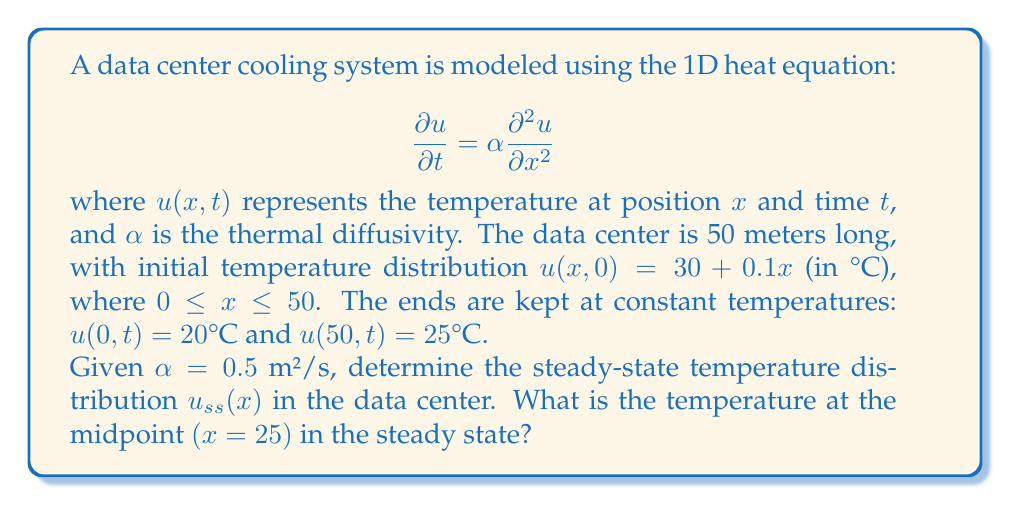Show me your answer to this math problem. To solve this problem, we'll follow these steps:

1) For the steady-state solution, the temperature doesn't change with time, so $\frac{\partial u}{\partial t} = 0$. The heat equation becomes:

   $$0 = \alpha \frac{d^2 u_{ss}}{dx^2}$$

2) Integrating twice:

   $$\frac{d u_{ss}}{dx} = C_1$$
   $$u_{ss}(x) = C_1x + C_2$$

3) Apply the boundary conditions:
   
   At $x=0$: $u_{ss}(0) = C_2 = 20$
   At $x=50$: $u_{ss}(50) = 50C_1 + 20 = 25$

4) Solve for $C_1$:

   $$50C_1 = 5$$
   $$C_1 = 0.1$$

5) The steady-state solution is:

   $$u_{ss}(x) = 0.1x + 20$$

6) To find the temperature at the midpoint $(x=25)$:

   $$u_{ss}(25) = 0.1(25) + 20 = 22.5°C$$
Answer: 22.5°C 